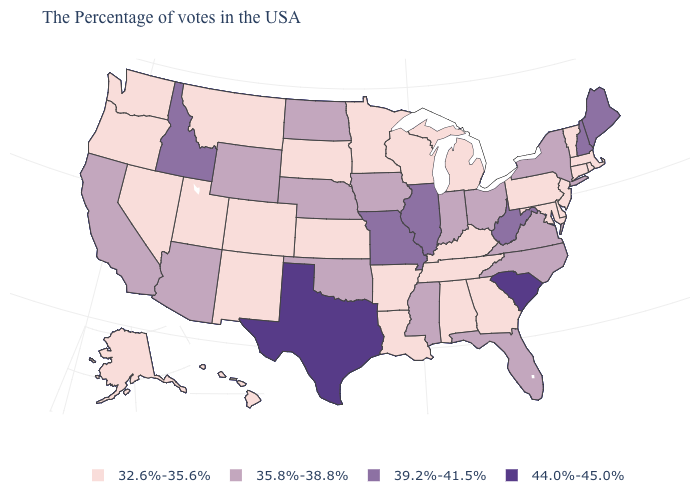Does South Carolina have the highest value in the USA?
Answer briefly. Yes. Name the states that have a value in the range 35.8%-38.8%?
Short answer required. New York, Virginia, North Carolina, Ohio, Florida, Indiana, Mississippi, Iowa, Nebraska, Oklahoma, North Dakota, Wyoming, Arizona, California. Which states have the highest value in the USA?
Write a very short answer. South Carolina, Texas. Which states have the highest value in the USA?
Write a very short answer. South Carolina, Texas. Does Nevada have the lowest value in the West?
Keep it brief. Yes. Among the states that border Texas , does Oklahoma have the highest value?
Concise answer only. Yes. Does North Dakota have the same value as Virginia?
Give a very brief answer. Yes. Does the map have missing data?
Give a very brief answer. No. Among the states that border Arizona , which have the lowest value?
Concise answer only. Colorado, New Mexico, Utah, Nevada. Among the states that border Maryland , does West Virginia have the highest value?
Answer briefly. Yes. Name the states that have a value in the range 32.6%-35.6%?
Write a very short answer. Massachusetts, Rhode Island, Vermont, Connecticut, New Jersey, Delaware, Maryland, Pennsylvania, Georgia, Michigan, Kentucky, Alabama, Tennessee, Wisconsin, Louisiana, Arkansas, Minnesota, Kansas, South Dakota, Colorado, New Mexico, Utah, Montana, Nevada, Washington, Oregon, Alaska, Hawaii. Name the states that have a value in the range 35.8%-38.8%?
Keep it brief. New York, Virginia, North Carolina, Ohio, Florida, Indiana, Mississippi, Iowa, Nebraska, Oklahoma, North Dakota, Wyoming, Arizona, California. Name the states that have a value in the range 39.2%-41.5%?
Write a very short answer. Maine, New Hampshire, West Virginia, Illinois, Missouri, Idaho. Name the states that have a value in the range 32.6%-35.6%?
Give a very brief answer. Massachusetts, Rhode Island, Vermont, Connecticut, New Jersey, Delaware, Maryland, Pennsylvania, Georgia, Michigan, Kentucky, Alabama, Tennessee, Wisconsin, Louisiana, Arkansas, Minnesota, Kansas, South Dakota, Colorado, New Mexico, Utah, Montana, Nevada, Washington, Oregon, Alaska, Hawaii. What is the lowest value in the USA?
Keep it brief. 32.6%-35.6%. 